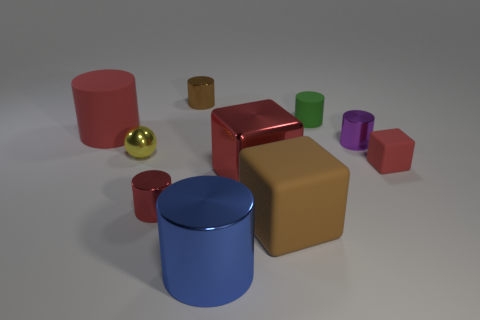Subtract all red cylinders. How many were subtracted if there are1red cylinders left? 1 Subtract all cyan cylinders. How many red blocks are left? 2 Subtract all rubber cubes. How many cubes are left? 1 Subtract 3 cylinders. How many cylinders are left? 3 Subtract all blue cylinders. How many cylinders are left? 5 Subtract all spheres. How many objects are left? 9 Subtract all gray cylinders. Subtract all gray spheres. How many cylinders are left? 6 Subtract all large blue metal things. Subtract all large cubes. How many objects are left? 7 Add 7 big blocks. How many big blocks are left? 9 Add 3 large things. How many large things exist? 7 